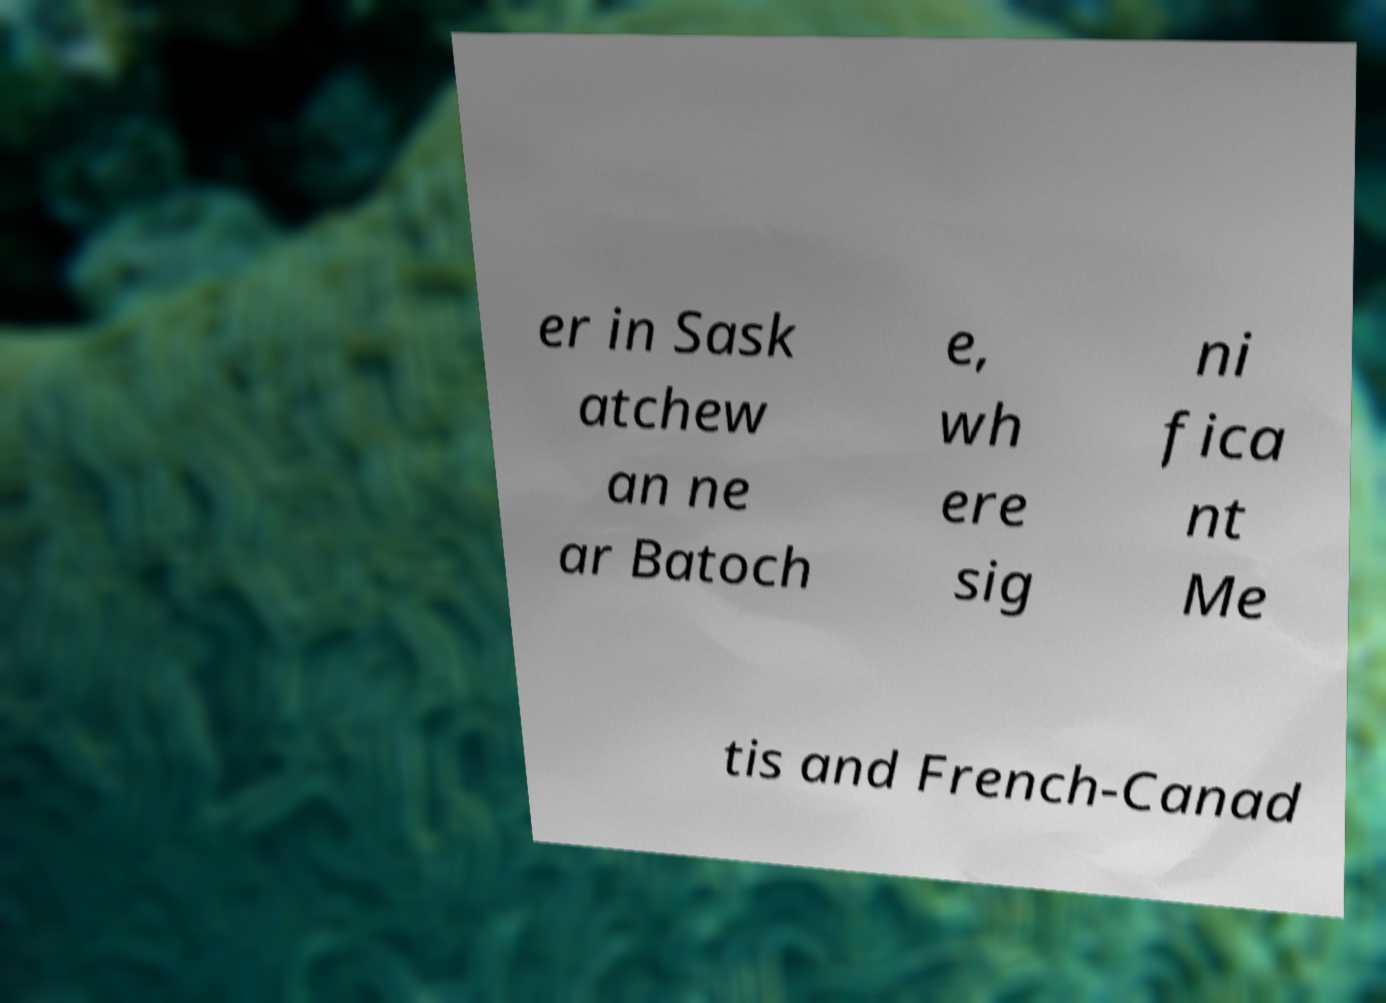Could you extract and type out the text from this image? er in Sask atchew an ne ar Batoch e, wh ere sig ni fica nt Me tis and French-Canad 